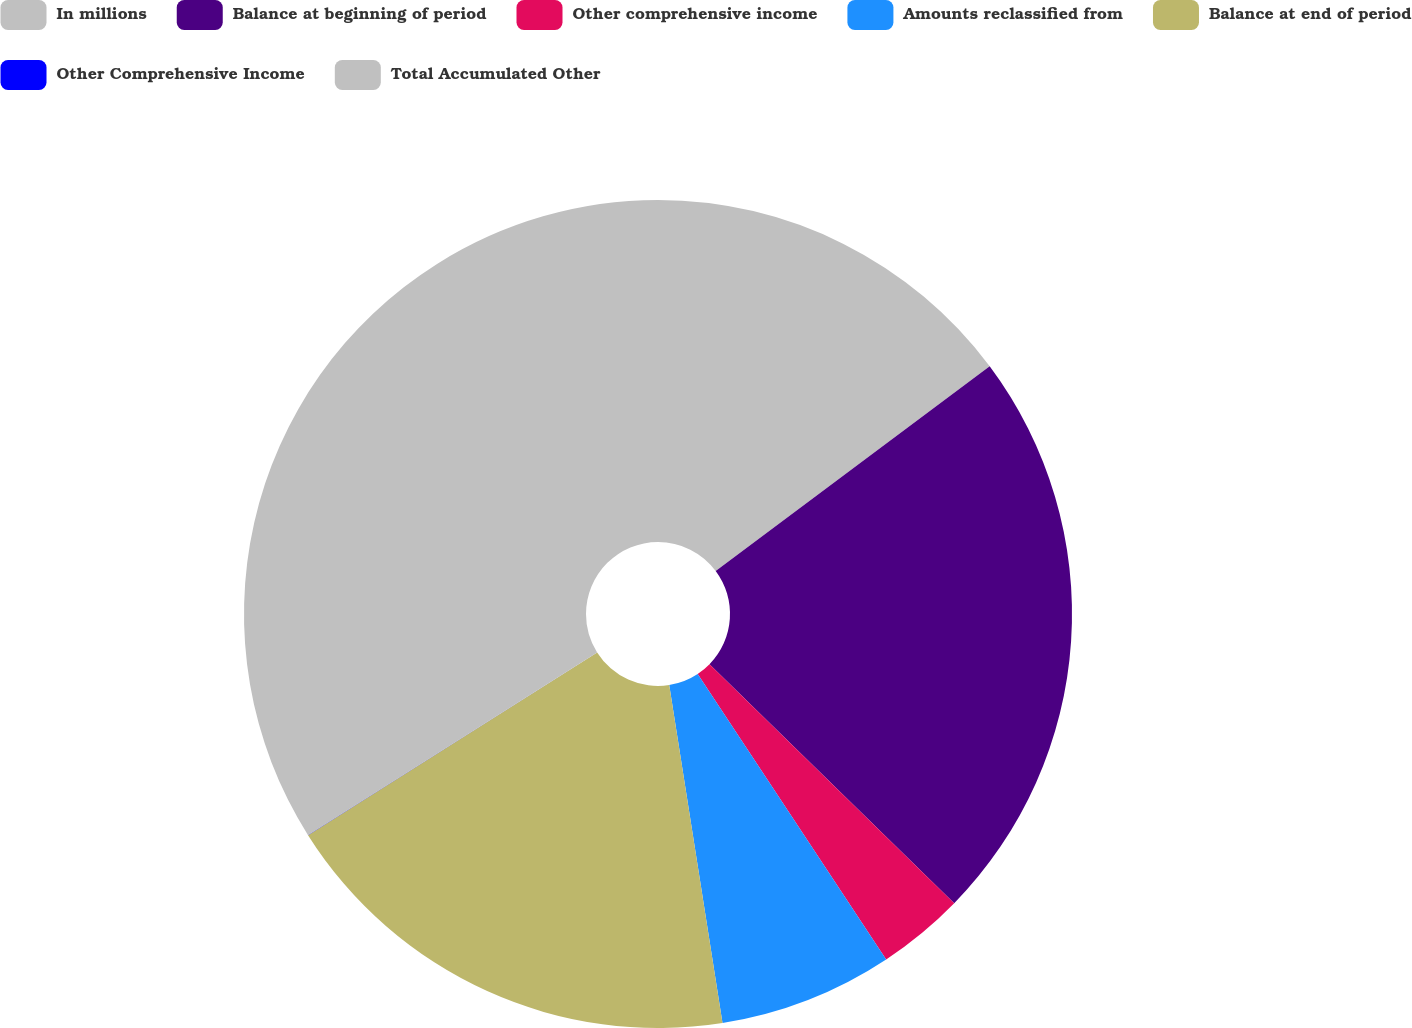<chart> <loc_0><loc_0><loc_500><loc_500><pie_chart><fcel>In millions<fcel>Balance at beginning of period<fcel>Other comprehensive income<fcel>Amounts reclassified from<fcel>Balance at end of period<fcel>Other Comprehensive Income<fcel>Total Accumulated Other<nl><fcel>14.79%<fcel>22.52%<fcel>3.4%<fcel>6.8%<fcel>18.52%<fcel>0.01%<fcel>33.96%<nl></chart> 